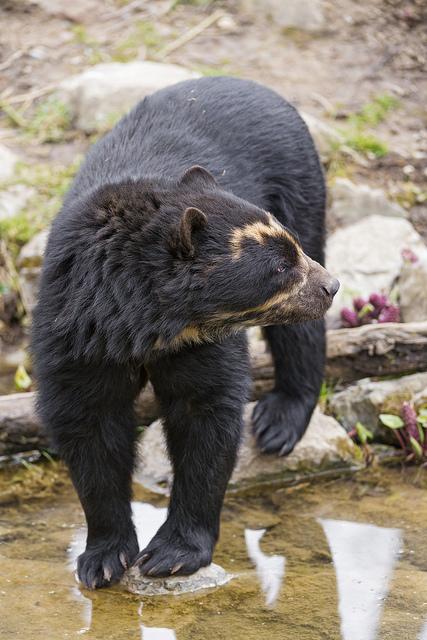What animal is this?
Keep it brief. Bear. Are all four paws visible?
Short answer required. No. Is there any mold?
Quick response, please. No. What plant is in the background?
Short answer required. Weeds. 